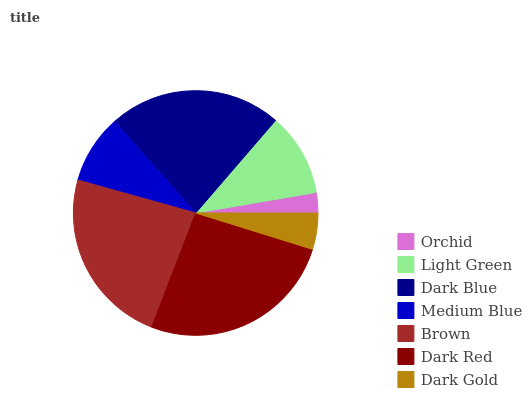Is Orchid the minimum?
Answer yes or no. Yes. Is Dark Red the maximum?
Answer yes or no. Yes. Is Light Green the minimum?
Answer yes or no. No. Is Light Green the maximum?
Answer yes or no. No. Is Light Green greater than Orchid?
Answer yes or no. Yes. Is Orchid less than Light Green?
Answer yes or no. Yes. Is Orchid greater than Light Green?
Answer yes or no. No. Is Light Green less than Orchid?
Answer yes or no. No. Is Light Green the high median?
Answer yes or no. Yes. Is Light Green the low median?
Answer yes or no. Yes. Is Medium Blue the high median?
Answer yes or no. No. Is Dark Blue the low median?
Answer yes or no. No. 